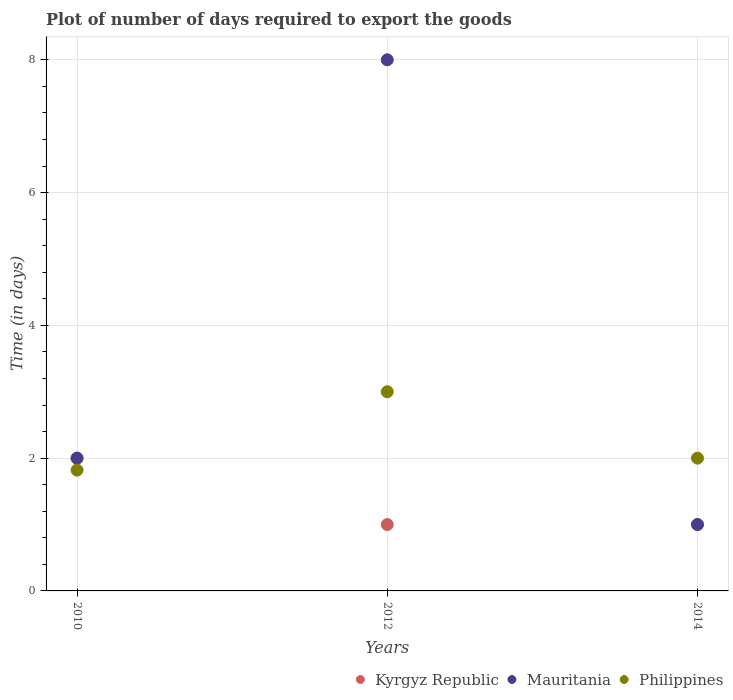How many different coloured dotlines are there?
Your answer should be very brief. 3. Is the number of dotlines equal to the number of legend labels?
Offer a very short reply. Yes. What is the time required to export goods in Mauritania in 2012?
Provide a short and direct response. 8. Across all years, what is the minimum time required to export goods in Mauritania?
Provide a succinct answer. 1. In which year was the time required to export goods in Kyrgyz Republic minimum?
Your answer should be compact. 2012. What is the total time required to export goods in Kyrgyz Republic in the graph?
Make the answer very short. 4. What is the difference between the time required to export goods in Philippines in 2012 and the time required to export goods in Mauritania in 2010?
Offer a very short reply. 1. What is the average time required to export goods in Philippines per year?
Make the answer very short. 2.27. In the year 2012, what is the difference between the time required to export goods in Kyrgyz Republic and time required to export goods in Mauritania?
Your response must be concise. -7. What is the difference between the highest and the second highest time required to export goods in Kyrgyz Republic?
Ensure brevity in your answer.  1. What is the difference between the highest and the lowest time required to export goods in Philippines?
Give a very brief answer. 1.18. Is the sum of the time required to export goods in Mauritania in 2010 and 2014 greater than the maximum time required to export goods in Philippines across all years?
Ensure brevity in your answer.  No. Is it the case that in every year, the sum of the time required to export goods in Kyrgyz Republic and time required to export goods in Philippines  is greater than the time required to export goods in Mauritania?
Keep it short and to the point. No. Does the time required to export goods in Philippines monotonically increase over the years?
Ensure brevity in your answer.  No. Is the time required to export goods in Philippines strictly less than the time required to export goods in Kyrgyz Republic over the years?
Provide a short and direct response. No. How many years are there in the graph?
Your answer should be very brief. 3. What is the difference between two consecutive major ticks on the Y-axis?
Make the answer very short. 2. Are the values on the major ticks of Y-axis written in scientific E-notation?
Provide a succinct answer. No. Does the graph contain any zero values?
Make the answer very short. No. Does the graph contain grids?
Make the answer very short. Yes. What is the title of the graph?
Ensure brevity in your answer.  Plot of number of days required to export the goods. What is the label or title of the X-axis?
Provide a succinct answer. Years. What is the label or title of the Y-axis?
Make the answer very short. Time (in days). What is the Time (in days) of Philippines in 2010?
Give a very brief answer. 1.82. What is the Time (in days) in Kyrgyz Republic in 2012?
Provide a succinct answer. 1. What is the Time (in days) of Mauritania in 2012?
Provide a short and direct response. 8. What is the Time (in days) of Mauritania in 2014?
Make the answer very short. 1. What is the Time (in days) of Philippines in 2014?
Provide a short and direct response. 2. Across all years, what is the maximum Time (in days) of Kyrgyz Republic?
Give a very brief answer. 2. Across all years, what is the minimum Time (in days) of Philippines?
Your answer should be compact. 1.82. What is the total Time (in days) in Mauritania in the graph?
Provide a short and direct response. 11. What is the total Time (in days) in Philippines in the graph?
Provide a succinct answer. 6.82. What is the difference between the Time (in days) in Philippines in 2010 and that in 2012?
Your answer should be compact. -1.18. What is the difference between the Time (in days) in Mauritania in 2010 and that in 2014?
Your answer should be compact. 1. What is the difference between the Time (in days) in Philippines in 2010 and that in 2014?
Your answer should be compact. -0.18. What is the difference between the Time (in days) in Kyrgyz Republic in 2012 and that in 2014?
Your answer should be very brief. 0. What is the difference between the Time (in days) in Mauritania in 2012 and that in 2014?
Offer a terse response. 7. What is the difference between the Time (in days) in Kyrgyz Republic in 2010 and the Time (in days) in Philippines in 2012?
Offer a terse response. -1. What is the difference between the Time (in days) of Mauritania in 2010 and the Time (in days) of Philippines in 2012?
Your response must be concise. -1. What is the difference between the Time (in days) of Kyrgyz Republic in 2010 and the Time (in days) of Philippines in 2014?
Offer a terse response. 0. What is the difference between the Time (in days) in Kyrgyz Republic in 2012 and the Time (in days) in Mauritania in 2014?
Make the answer very short. 0. What is the difference between the Time (in days) in Mauritania in 2012 and the Time (in days) in Philippines in 2014?
Offer a terse response. 6. What is the average Time (in days) in Mauritania per year?
Give a very brief answer. 3.67. What is the average Time (in days) of Philippines per year?
Offer a terse response. 2.27. In the year 2010, what is the difference between the Time (in days) in Kyrgyz Republic and Time (in days) in Mauritania?
Provide a succinct answer. 0. In the year 2010, what is the difference between the Time (in days) of Kyrgyz Republic and Time (in days) of Philippines?
Your response must be concise. 0.18. In the year 2010, what is the difference between the Time (in days) in Mauritania and Time (in days) in Philippines?
Give a very brief answer. 0.18. What is the ratio of the Time (in days) in Mauritania in 2010 to that in 2012?
Provide a short and direct response. 0.25. What is the ratio of the Time (in days) in Philippines in 2010 to that in 2012?
Your answer should be compact. 0.61. What is the ratio of the Time (in days) of Kyrgyz Republic in 2010 to that in 2014?
Your response must be concise. 2. What is the ratio of the Time (in days) of Philippines in 2010 to that in 2014?
Ensure brevity in your answer.  0.91. What is the ratio of the Time (in days) in Mauritania in 2012 to that in 2014?
Provide a short and direct response. 8. What is the difference between the highest and the second highest Time (in days) in Philippines?
Your answer should be very brief. 1. What is the difference between the highest and the lowest Time (in days) of Kyrgyz Republic?
Provide a succinct answer. 1. What is the difference between the highest and the lowest Time (in days) in Philippines?
Make the answer very short. 1.18. 